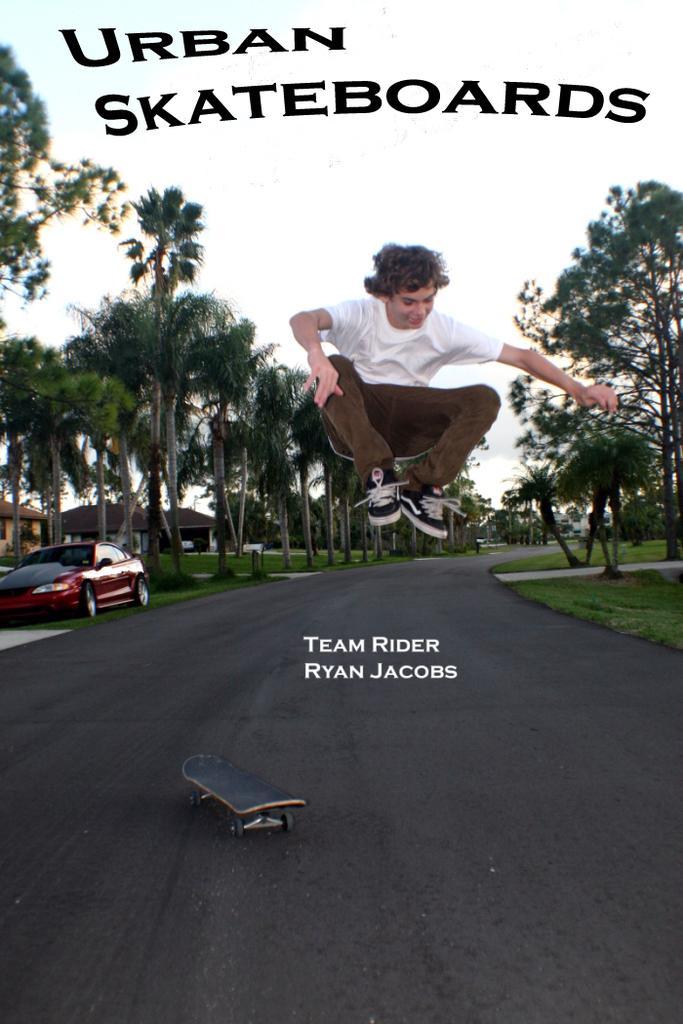In one or two sentences, can you explain what this image depicts? In the given picture, We can see a person, Who is jumping and a skateboard after that, We can see a car which is parked, couples of trees a road, sky. 